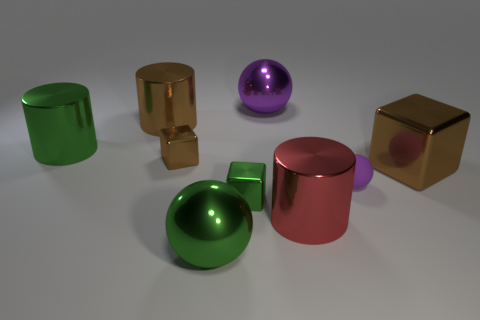What is the big green sphere made of?
Give a very brief answer. Metal. Is the material of the tiny purple object the same as the cylinder in front of the small brown shiny object?
Give a very brief answer. No. The metal cylinder in front of the big brown thing that is to the right of the small matte object is what color?
Offer a terse response. Red. There is a object that is both behind the tiny sphere and right of the red object; how big is it?
Make the answer very short. Large. How many other objects are the same shape as the purple matte thing?
Your response must be concise. 2. Is the shape of the tiny purple rubber object the same as the brown metal object that is right of the matte sphere?
Provide a short and direct response. No. What number of shiny objects are on the right side of the red metal cylinder?
Provide a succinct answer. 1. Are there any other things that are made of the same material as the tiny ball?
Your answer should be very brief. No. There is a large brown object right of the green cube; is it the same shape as the purple matte object?
Your answer should be compact. No. There is a small shiny cube that is on the left side of the green ball; what color is it?
Give a very brief answer. Brown. 